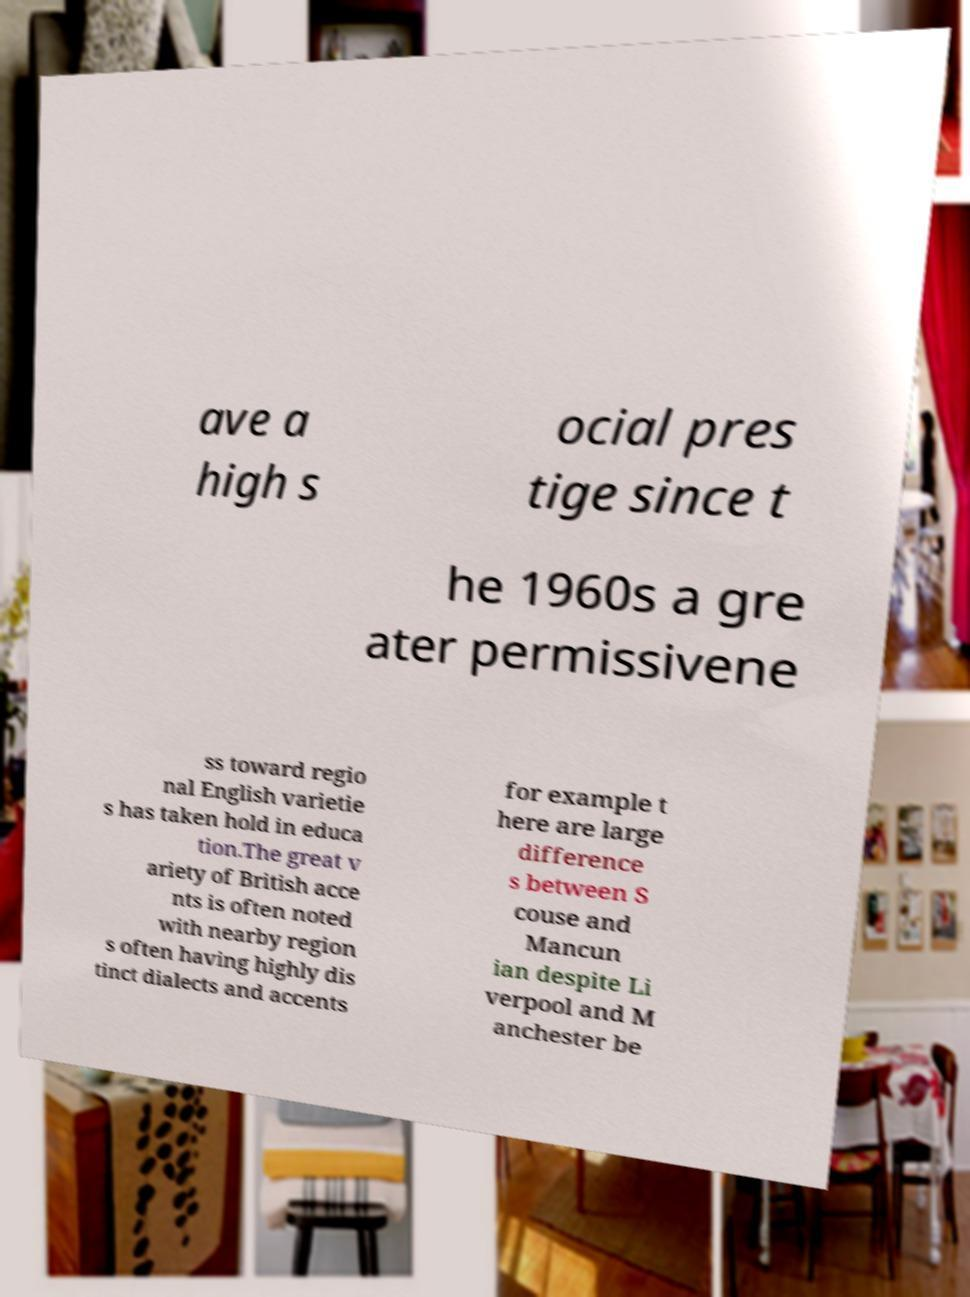For documentation purposes, I need the text within this image transcribed. Could you provide that? ave a high s ocial pres tige since t he 1960s a gre ater permissivene ss toward regio nal English varietie s has taken hold in educa tion.The great v ariety of British acce nts is often noted with nearby region s often having highly dis tinct dialects and accents for example t here are large difference s between S couse and Mancun ian despite Li verpool and M anchester be 